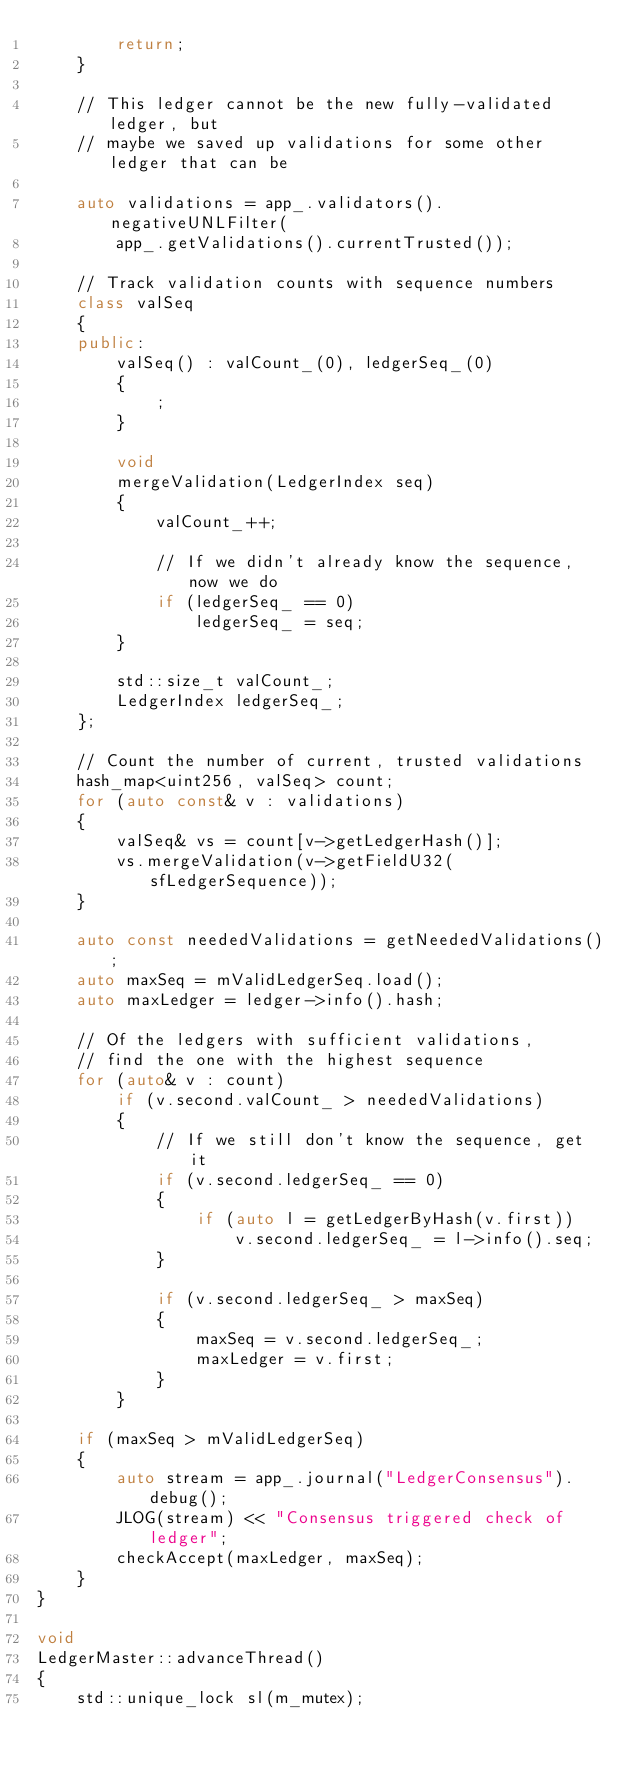<code> <loc_0><loc_0><loc_500><loc_500><_C++_>        return;
    }

    // This ledger cannot be the new fully-validated ledger, but
    // maybe we saved up validations for some other ledger that can be

    auto validations = app_.validators().negativeUNLFilter(
        app_.getValidations().currentTrusted());

    // Track validation counts with sequence numbers
    class valSeq
    {
    public:
        valSeq() : valCount_(0), ledgerSeq_(0)
        {
            ;
        }

        void
        mergeValidation(LedgerIndex seq)
        {
            valCount_++;

            // If we didn't already know the sequence, now we do
            if (ledgerSeq_ == 0)
                ledgerSeq_ = seq;
        }

        std::size_t valCount_;
        LedgerIndex ledgerSeq_;
    };

    // Count the number of current, trusted validations
    hash_map<uint256, valSeq> count;
    for (auto const& v : validations)
    {
        valSeq& vs = count[v->getLedgerHash()];
        vs.mergeValidation(v->getFieldU32(sfLedgerSequence));
    }

    auto const neededValidations = getNeededValidations();
    auto maxSeq = mValidLedgerSeq.load();
    auto maxLedger = ledger->info().hash;

    // Of the ledgers with sufficient validations,
    // find the one with the highest sequence
    for (auto& v : count)
        if (v.second.valCount_ > neededValidations)
        {
            // If we still don't know the sequence, get it
            if (v.second.ledgerSeq_ == 0)
            {
                if (auto l = getLedgerByHash(v.first))
                    v.second.ledgerSeq_ = l->info().seq;
            }

            if (v.second.ledgerSeq_ > maxSeq)
            {
                maxSeq = v.second.ledgerSeq_;
                maxLedger = v.first;
            }
        }

    if (maxSeq > mValidLedgerSeq)
    {
        auto stream = app_.journal("LedgerConsensus").debug();
        JLOG(stream) << "Consensus triggered check of ledger";
        checkAccept(maxLedger, maxSeq);
    }
}

void
LedgerMaster::advanceThread()
{
    std::unique_lock sl(m_mutex);</code> 